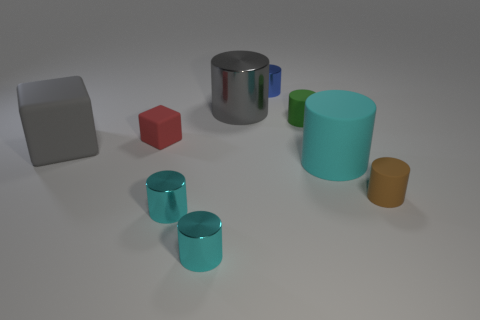What material is the big thing that is both in front of the tiny green rubber cylinder and on the left side of the small green matte cylinder?
Your answer should be compact. Rubber. How many things are either small matte things that are behind the big gray rubber block or cyan metal things?
Ensure brevity in your answer.  4. Does the big shiny object have the same color as the large matte cube?
Your response must be concise. Yes. Is there a gray cylinder that has the same size as the red rubber cube?
Your answer should be very brief. No. How many objects are both in front of the gray matte thing and behind the tiny brown object?
Make the answer very short. 1. What number of tiny blue metallic things are right of the green matte cylinder?
Give a very brief answer. 0. Is there a small cyan metal thing that has the same shape as the blue object?
Your answer should be very brief. Yes. There is a small green thing; does it have the same shape as the large matte object that is left of the green thing?
Offer a very short reply. No. How many cubes are either big gray matte things or cyan objects?
Make the answer very short. 1. There is a tiny metallic object that is behind the brown thing; what is its shape?
Make the answer very short. Cylinder. 